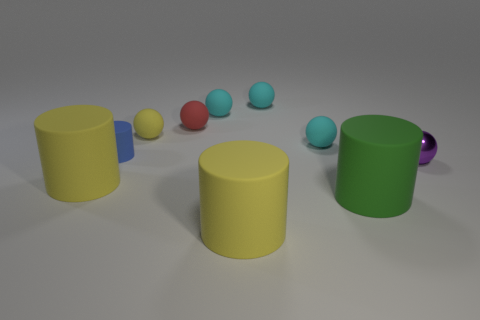What is the shape of the purple object?
Provide a succinct answer. Sphere. What size is the matte sphere that is both right of the small yellow rubber thing and in front of the small red thing?
Offer a very short reply. Small. What is the large yellow cylinder behind the large green object made of?
Offer a terse response. Rubber. What number of things are either cylinders to the left of the blue matte cylinder or tiny balls that are on the right side of the red sphere?
Your answer should be compact. 5. What color is the cylinder that is both on the right side of the small red object and left of the big green thing?
Provide a succinct answer. Yellow. Are there more blue things than small spheres?
Offer a very short reply. No. There is a yellow object that is left of the yellow ball; is its shape the same as the small yellow matte object?
Make the answer very short. No. How many metal things are either cylinders or cyan spheres?
Your response must be concise. 0. Is there a tiny purple cylinder that has the same material as the small red thing?
Offer a terse response. No. What is the purple ball made of?
Give a very brief answer. Metal. 